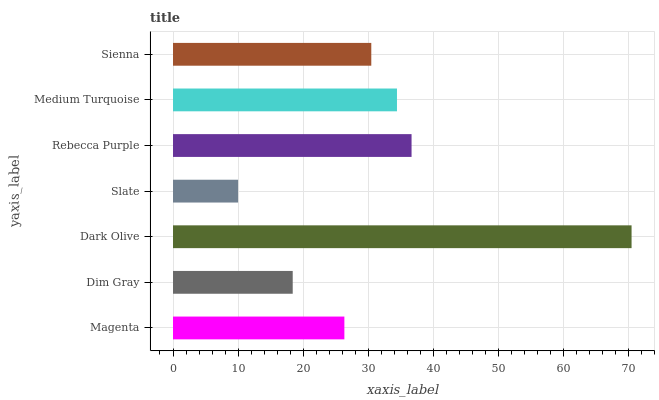Is Slate the minimum?
Answer yes or no. Yes. Is Dark Olive the maximum?
Answer yes or no. Yes. Is Dim Gray the minimum?
Answer yes or no. No. Is Dim Gray the maximum?
Answer yes or no. No. Is Magenta greater than Dim Gray?
Answer yes or no. Yes. Is Dim Gray less than Magenta?
Answer yes or no. Yes. Is Dim Gray greater than Magenta?
Answer yes or no. No. Is Magenta less than Dim Gray?
Answer yes or no. No. Is Sienna the high median?
Answer yes or no. Yes. Is Sienna the low median?
Answer yes or no. Yes. Is Medium Turquoise the high median?
Answer yes or no. No. Is Rebecca Purple the low median?
Answer yes or no. No. 